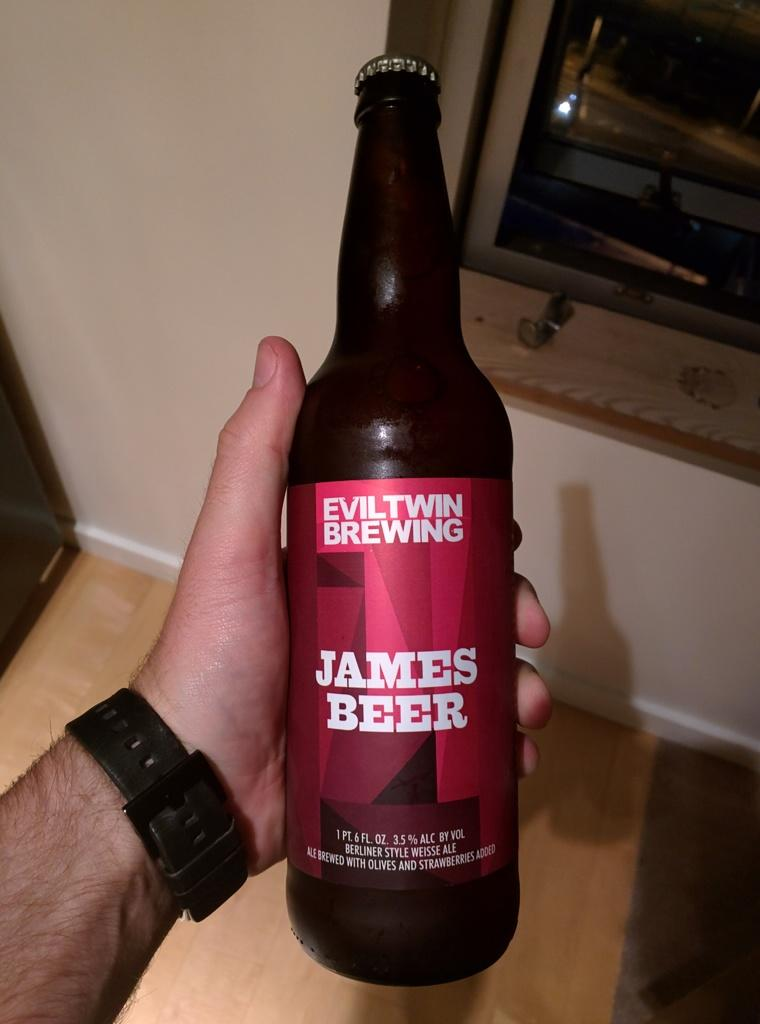Provide a one-sentence caption for the provided image. Man holding a bottle of "James Beer" by Eviltwin Brewing. 